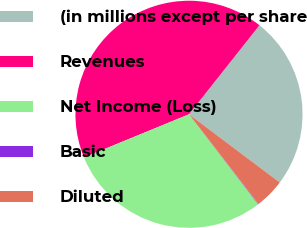<chart> <loc_0><loc_0><loc_500><loc_500><pie_chart><fcel>(in millions except per share<fcel>Revenues<fcel>Net Income (Loss)<fcel>Basic<fcel>Diluted<nl><fcel>24.6%<fcel>41.86%<fcel>29.22%<fcel>0.07%<fcel>4.25%<nl></chart> 